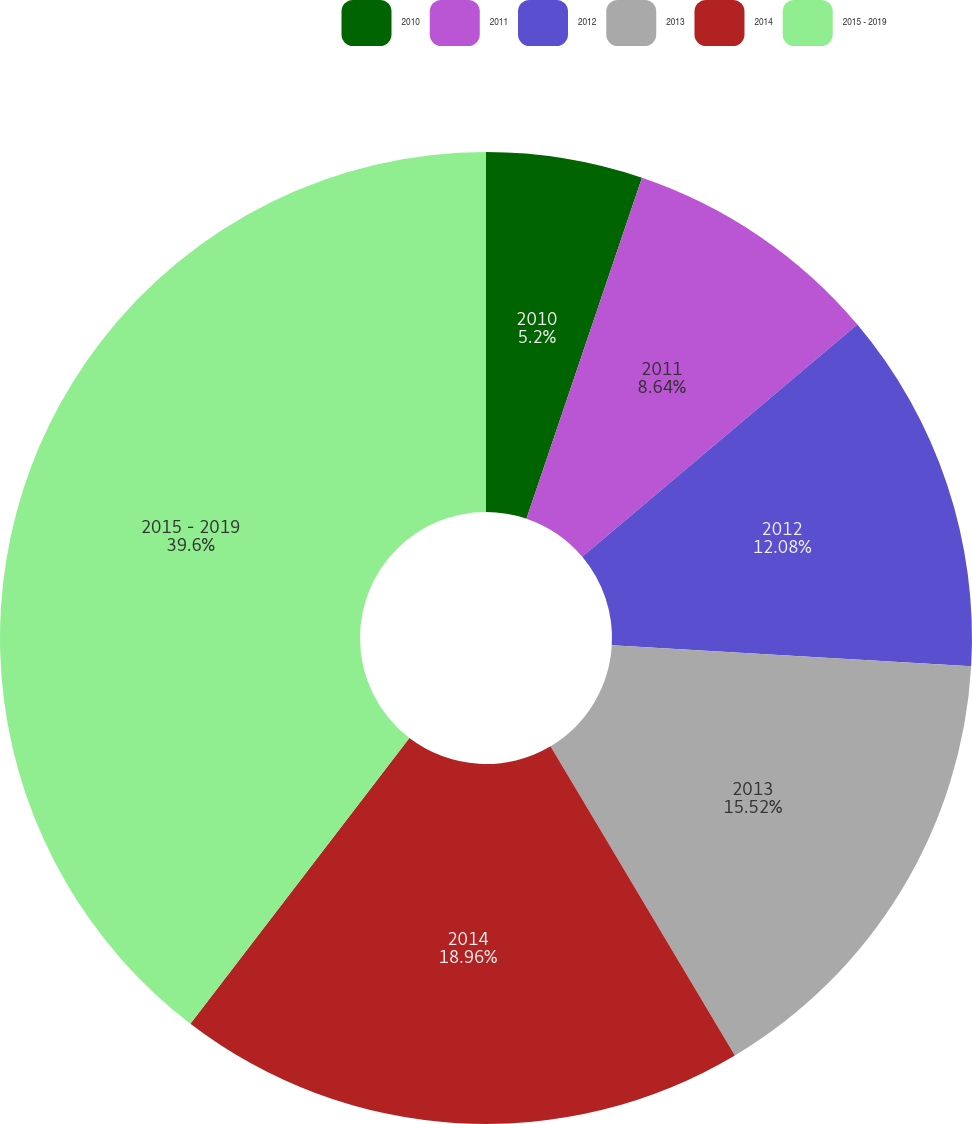Convert chart to OTSL. <chart><loc_0><loc_0><loc_500><loc_500><pie_chart><fcel>2010<fcel>2011<fcel>2012<fcel>2013<fcel>2014<fcel>2015 - 2019<nl><fcel>5.2%<fcel>8.64%<fcel>12.08%<fcel>15.52%<fcel>18.96%<fcel>39.59%<nl></chart> 